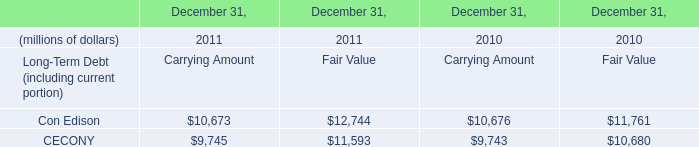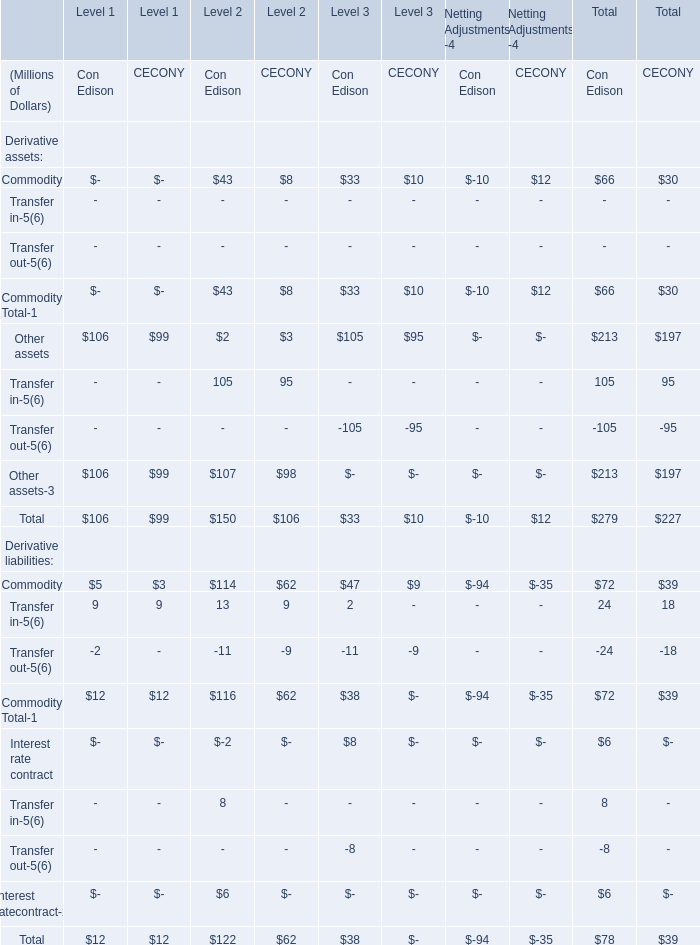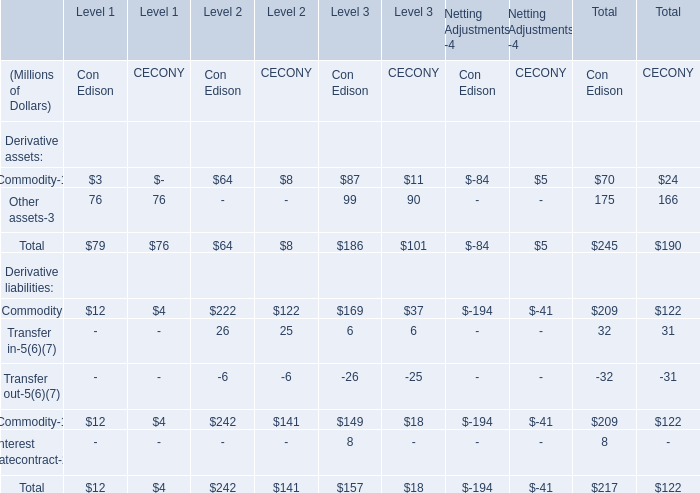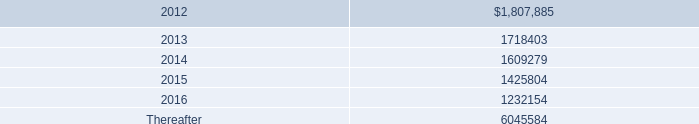What is the Total Derivative assets of Con Edison in the Level where Other assets of Con Edison is positive? (in million) 
Answer: 186. 